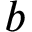<formula> <loc_0><loc_0><loc_500><loc_500>b</formula> 